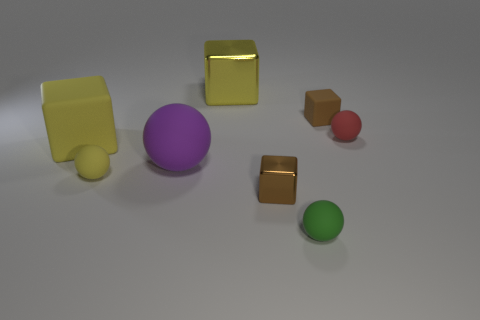Subtract all cyan balls. Subtract all blue blocks. How many balls are left? 4 Add 1 brown rubber things. How many objects exist? 9 Subtract all purple rubber spheres. Subtract all red things. How many objects are left? 6 Add 6 red rubber objects. How many red rubber objects are left? 7 Add 3 purple rubber things. How many purple rubber things exist? 4 Subtract 0 blue cylinders. How many objects are left? 8 